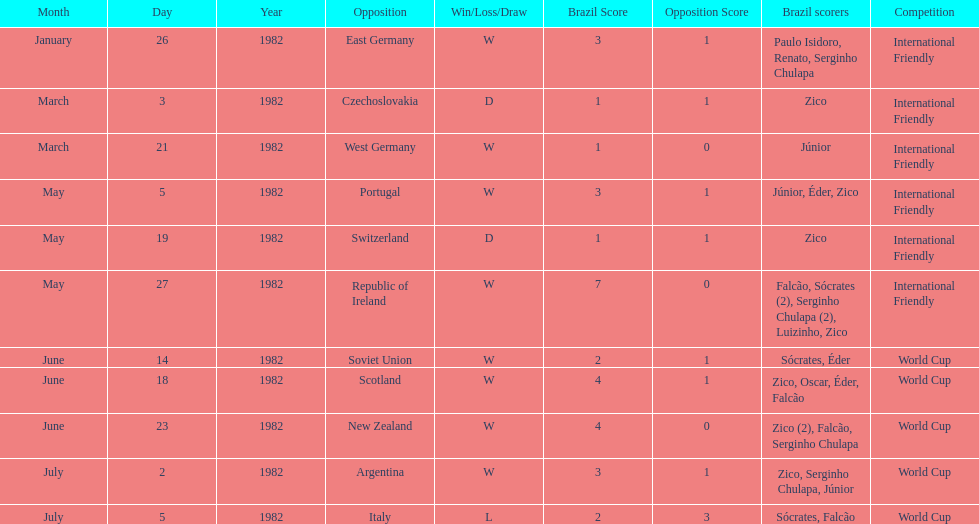What was the total number of losses brazil suffered? 1. 